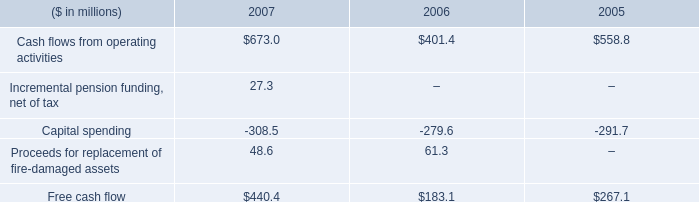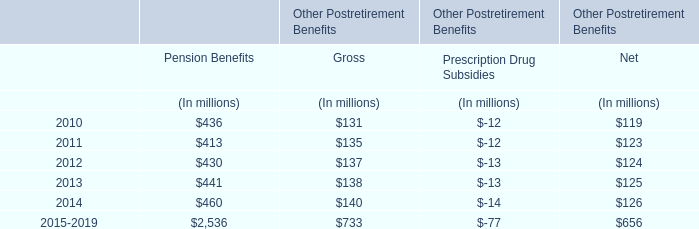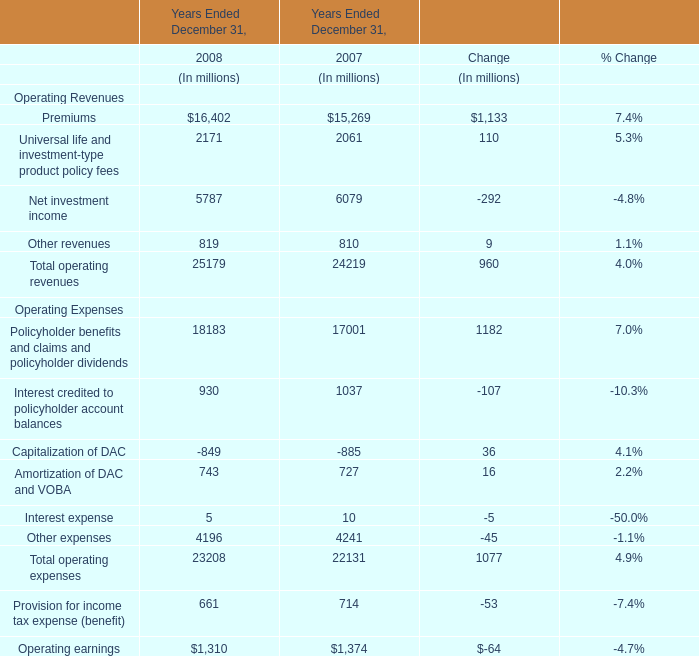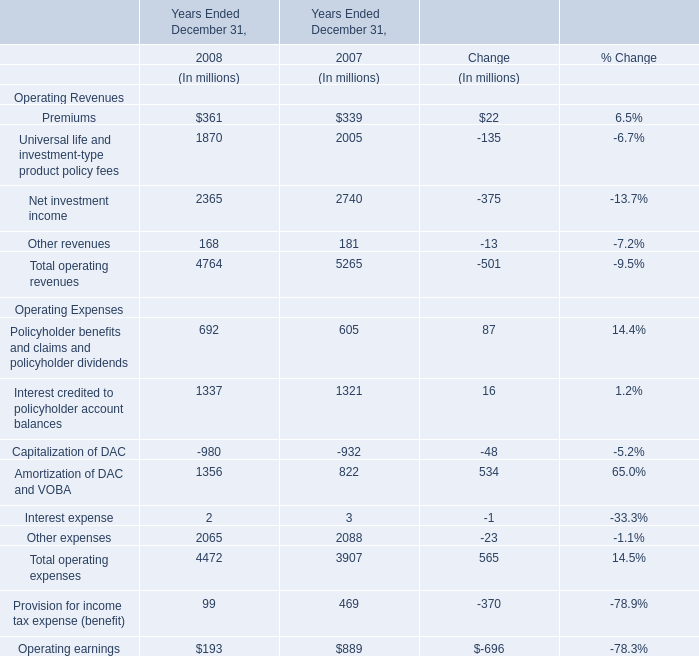What is the sum of Operating Revenues in 2008? 
Answer: 4764. 